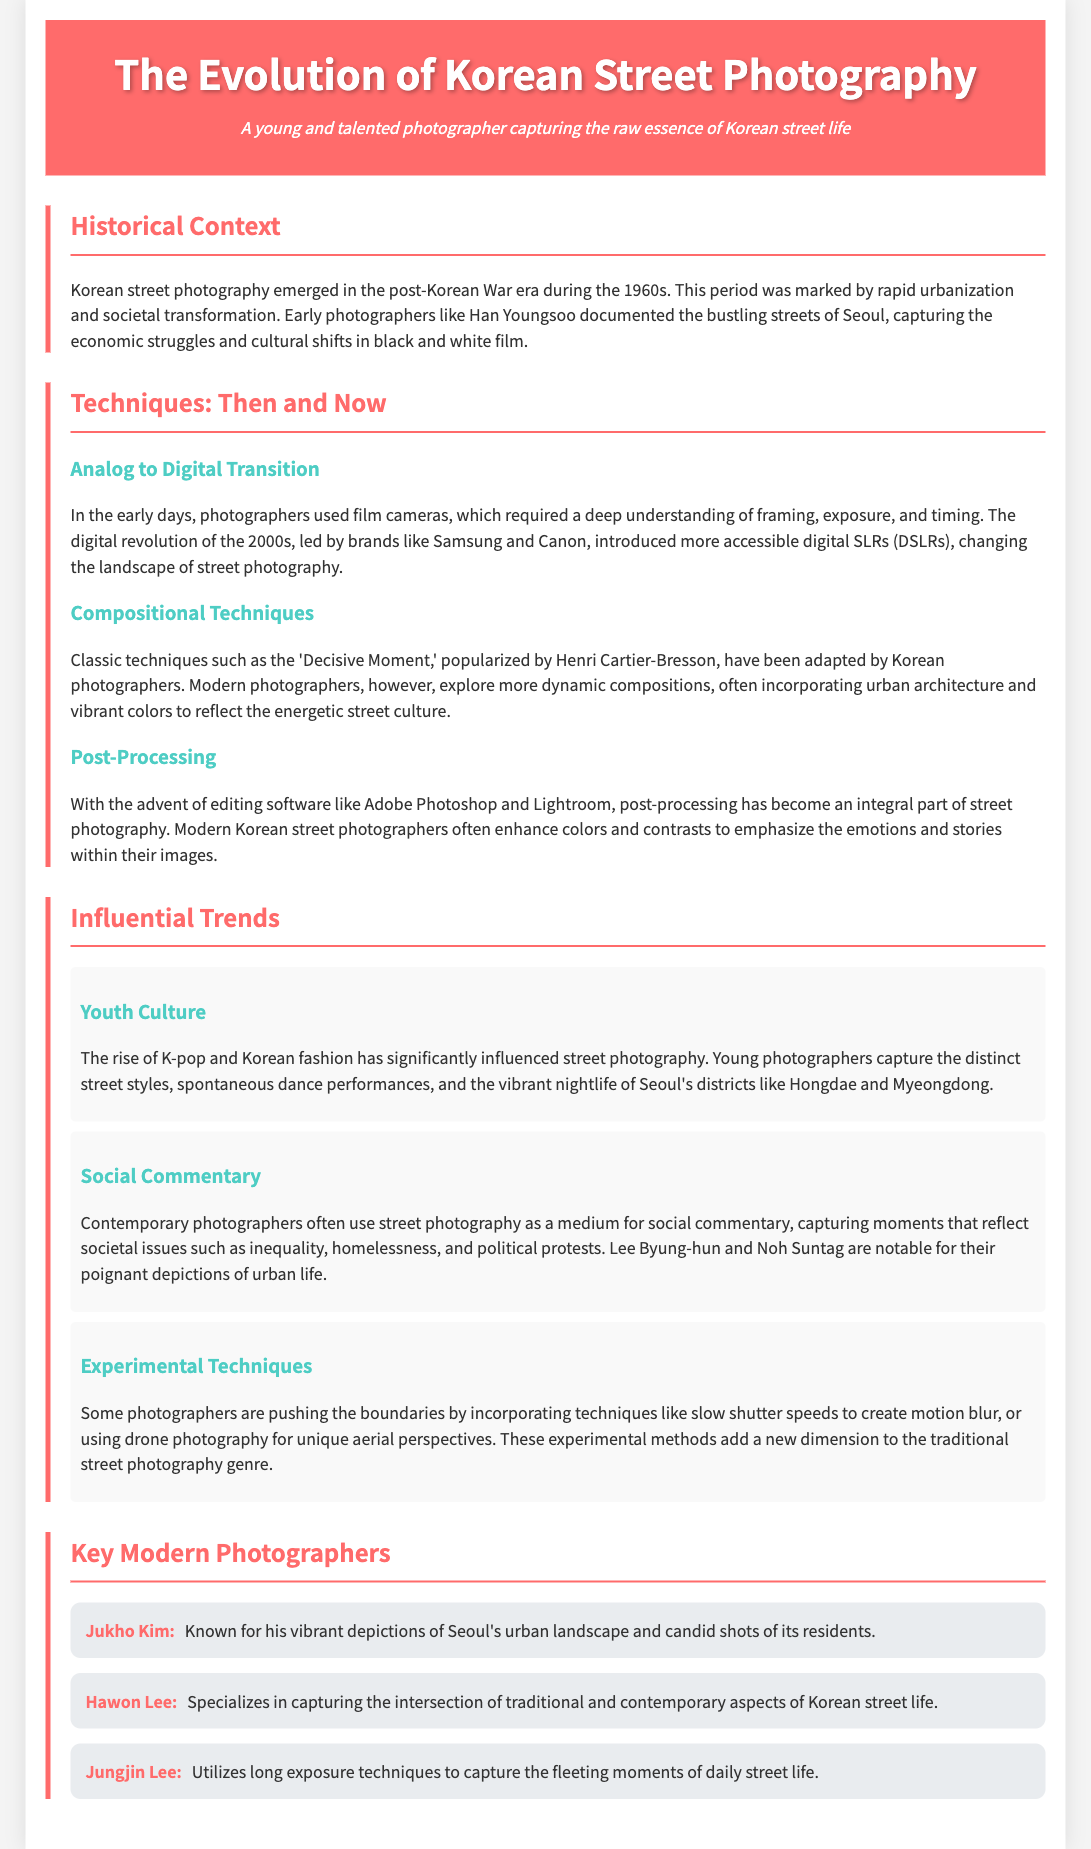what decade did Korean street photography emerge? The document states that Korean street photography emerged in the post-Korean War era during the 1960s.
Answer: 1960s who documented the bustling streets of Seoul in the early days? The document mentions Han Youngsoo as an early photographer who documented the streets of Seoul.
Answer: Han Youngsoo what photography transition is noted in the techniques section? The document discusses the transition from analog to digital photography techniques in Korean street photography.
Answer: Analog to Digital which technique is popularized by Henri Cartier-Bresson? The document refers to the 'Decisive Moment' as a technique popularized by Henri Cartier-Bresson.
Answer: Decisive Moment name one influential trend in Korean street photography. The document lists youth culture, social commentary, and experimental techniques as influential trends.
Answer: Youth Culture who is known for capturing the intersection of traditional and contemporary aspects? The document states that Hawon Lee specializes in capturing traditional and contemporary aspects of Korean street life.
Answer: Hawon Lee what editing software is mentioned in the post-processing section? The document mentions Adobe Photoshop and Lightroom as editing software used in post-processing.
Answer: Adobe Photoshop and Lightroom which districts are highlighted for vibrant nightlife in youth culture photography? The document specifically mentions Hongdae and Myeongdong as districts noted for vibrant nightlife.
Answer: Hongdae and Myeongdong how are modern photographers changing compositional techniques? The document indicates that modern photographers explore more dynamic compositions incorporating urban architecture and vibrant colors.
Answer: Dynamic compositions 